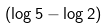Convert formula to latex. <formula><loc_0><loc_0><loc_500><loc_500>( \log 5 - \log 2 )</formula> 